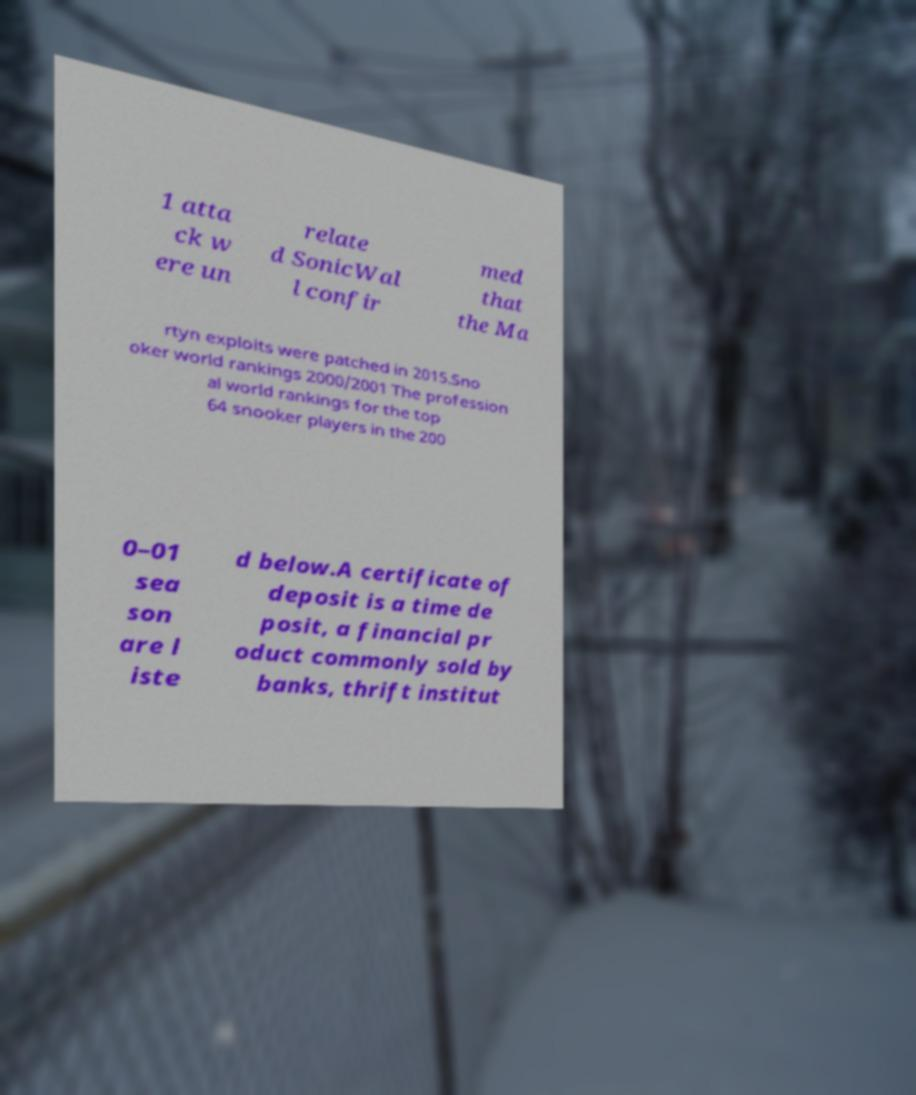Can you accurately transcribe the text from the provided image for me? 1 atta ck w ere un relate d SonicWal l confir med that the Ma rtyn exploits were patched in 2015.Sno oker world rankings 2000/2001 The profession al world rankings for the top 64 snooker players in the 200 0–01 sea son are l iste d below.A certificate of deposit is a time de posit, a financial pr oduct commonly sold by banks, thrift institut 